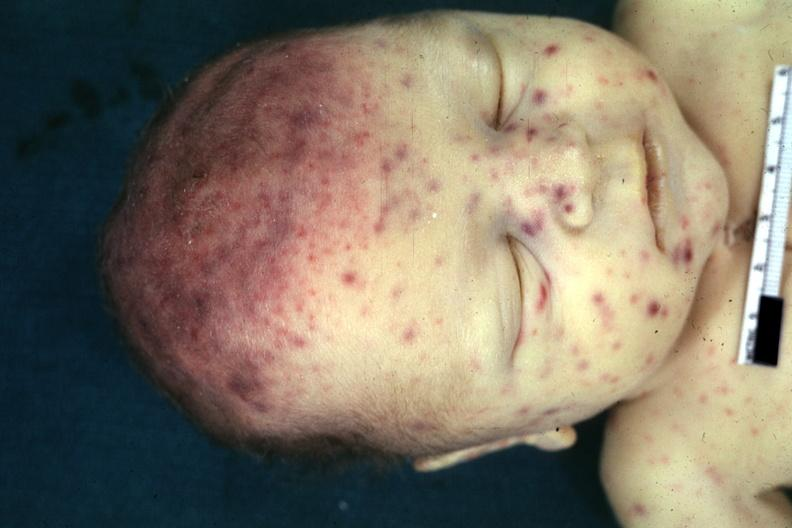what is present?
Answer the question using a single word or phrase. Cytomegalic inclusion virus infection in infant 